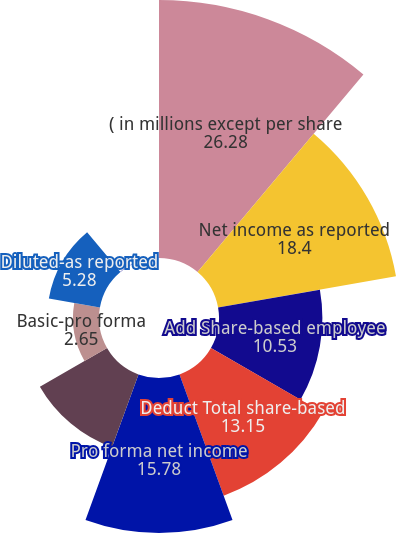<chart> <loc_0><loc_0><loc_500><loc_500><pie_chart><fcel>( in millions except per share<fcel>Net income as reported<fcel>Add Share-based employee<fcel>Deduct Total share-based<fcel>Pro forma net income<fcel>Basic-as reported<fcel>Basic-pro forma<fcel>Diluted-as reported<fcel>Diluted-pro forma<nl><fcel>26.28%<fcel>18.4%<fcel>10.53%<fcel>13.15%<fcel>15.78%<fcel>7.9%<fcel>2.65%<fcel>5.28%<fcel>0.03%<nl></chart> 